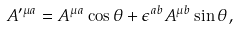Convert formula to latex. <formula><loc_0><loc_0><loc_500><loc_500>A ^ { \prime \mu a } = A ^ { \mu a } \cos \theta + \epsilon ^ { a b } A ^ { \mu b } \sin \theta ,</formula> 